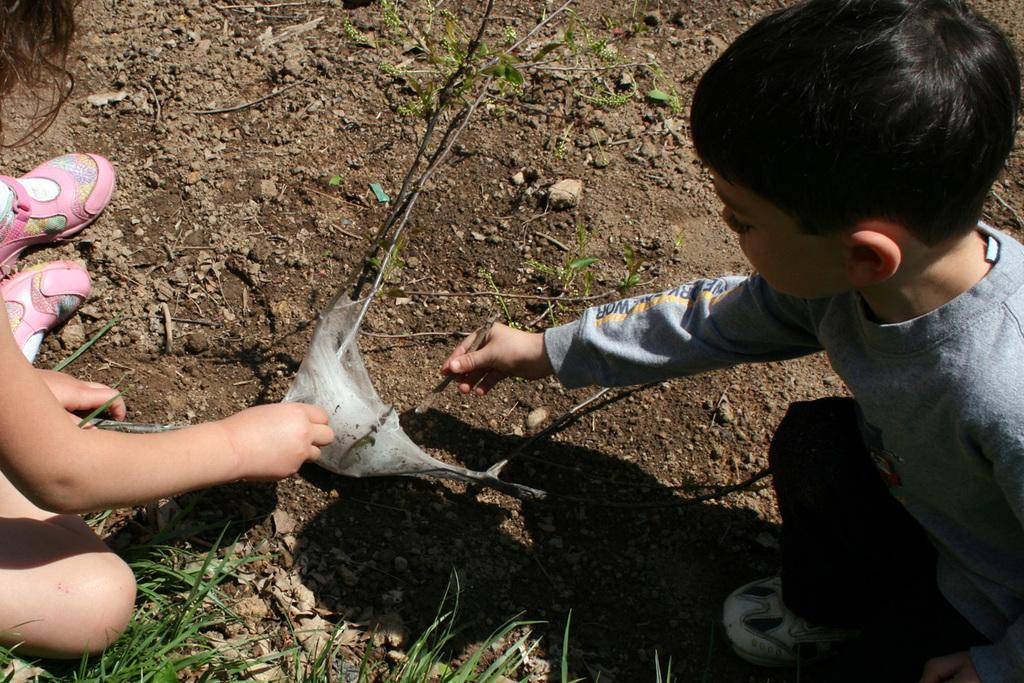Could you give a brief overview of what you see in this image? In this image there are two children sitting and doing something on the surface, one of them is holding a wooden stick in his hand, in front of them there is a plant and something like a cotton. At the bottom of the image there is a grass. 